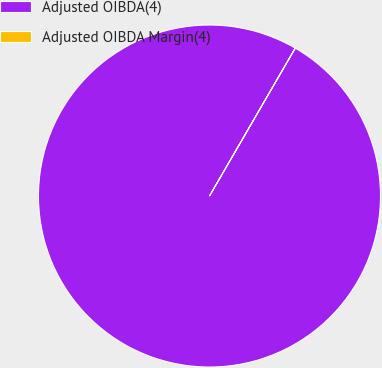Convert chart. <chart><loc_0><loc_0><loc_500><loc_500><pie_chart><fcel>Adjusted OIBDA(4)<fcel>Adjusted OIBDA Margin(4)<nl><fcel>100.0%<fcel>0.0%<nl></chart> 